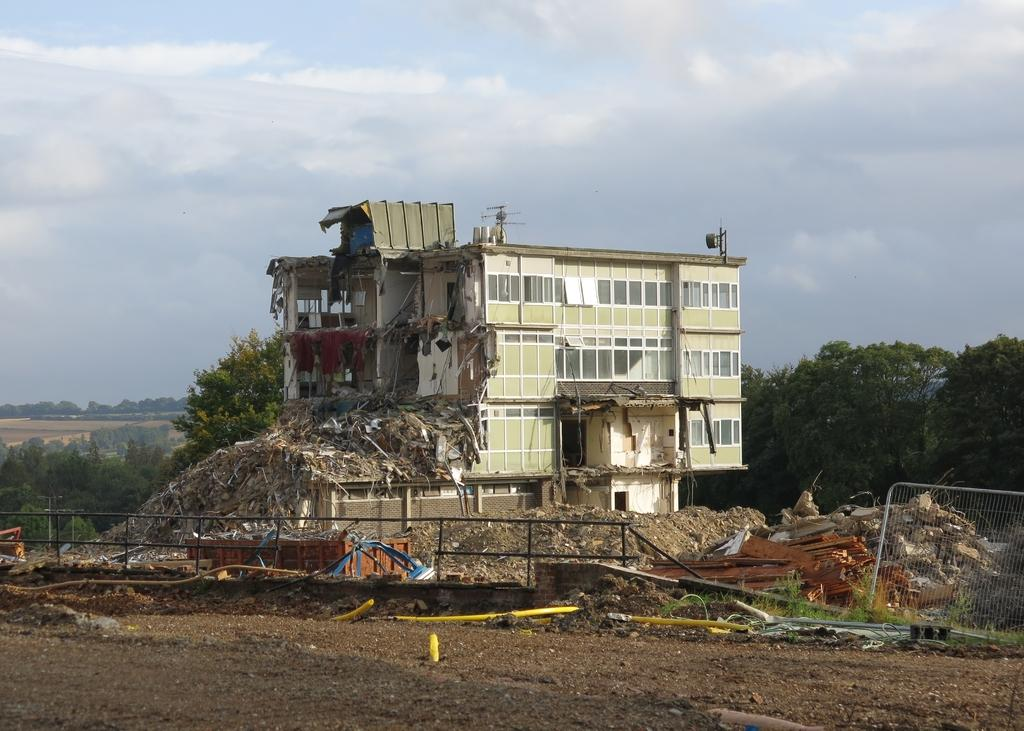What type of structure can be seen in the image? There is fencing in the image. What is the condition of the building in the image? There is a collapsed building in the image. What can be seen in the background of the image? There are trees and the sky visible in the background of the image. Can you see a snail crawling on the collapsed building in the image? There is no snail visible on the collapsed building in the image. What type of wrist accessory is worn by the trees in the background? The trees in the background do not have wrist accessories; they are natural vegetation. 